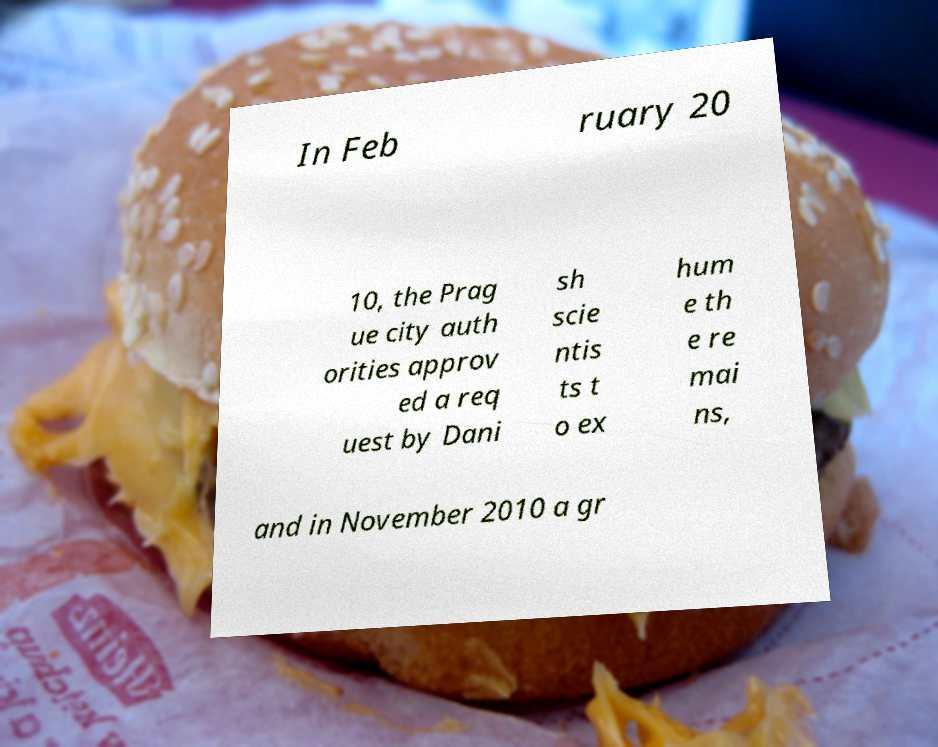What messages or text are displayed in this image? I need them in a readable, typed format. In Feb ruary 20 10, the Prag ue city auth orities approv ed a req uest by Dani sh scie ntis ts t o ex hum e th e re mai ns, and in November 2010 a gr 